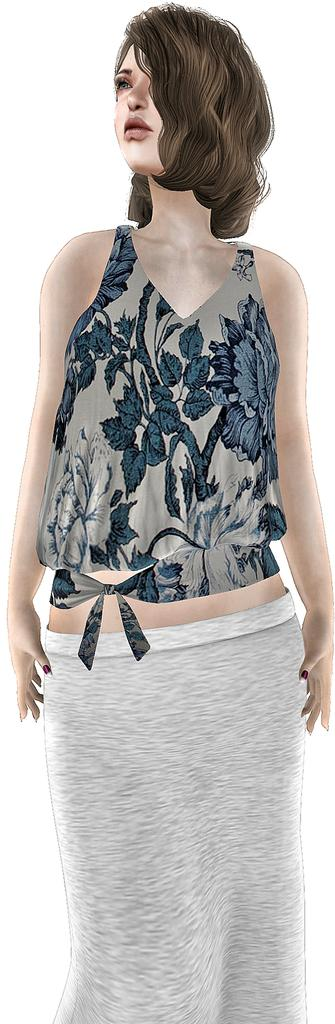Who is in the image? There is a person in the image, specifically a woman. What is the woman wearing? The woman is wearing a blue dress. What color is the background of the image? The background of the image is white. What flavor of ice cream is the woman holding in the image? There is no ice cream present in the image, so it is not possible to determine the flavor. 